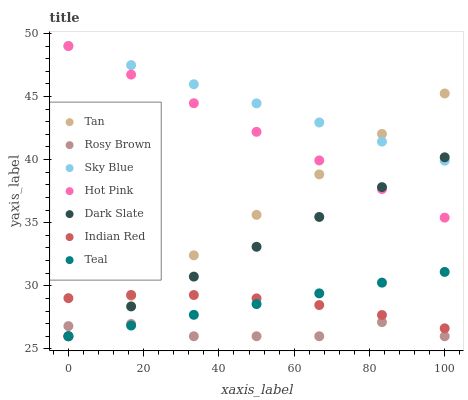Does Rosy Brown have the minimum area under the curve?
Answer yes or no. Yes. Does Sky Blue have the maximum area under the curve?
Answer yes or no. Yes. Does Teal have the minimum area under the curve?
Answer yes or no. No. Does Teal have the maximum area under the curve?
Answer yes or no. No. Is Teal the smoothest?
Answer yes or no. Yes. Is Rosy Brown the roughest?
Answer yes or no. Yes. Is Rosy Brown the smoothest?
Answer yes or no. No. Is Teal the roughest?
Answer yes or no. No. Does Teal have the lowest value?
Answer yes or no. Yes. Does Indian Red have the lowest value?
Answer yes or no. No. Does Sky Blue have the highest value?
Answer yes or no. Yes. Does Teal have the highest value?
Answer yes or no. No. Is Indian Red less than Sky Blue?
Answer yes or no. Yes. Is Hot Pink greater than Indian Red?
Answer yes or no. Yes. Does Dark Slate intersect Rosy Brown?
Answer yes or no. Yes. Is Dark Slate less than Rosy Brown?
Answer yes or no. No. Is Dark Slate greater than Rosy Brown?
Answer yes or no. No. Does Indian Red intersect Sky Blue?
Answer yes or no. No. 